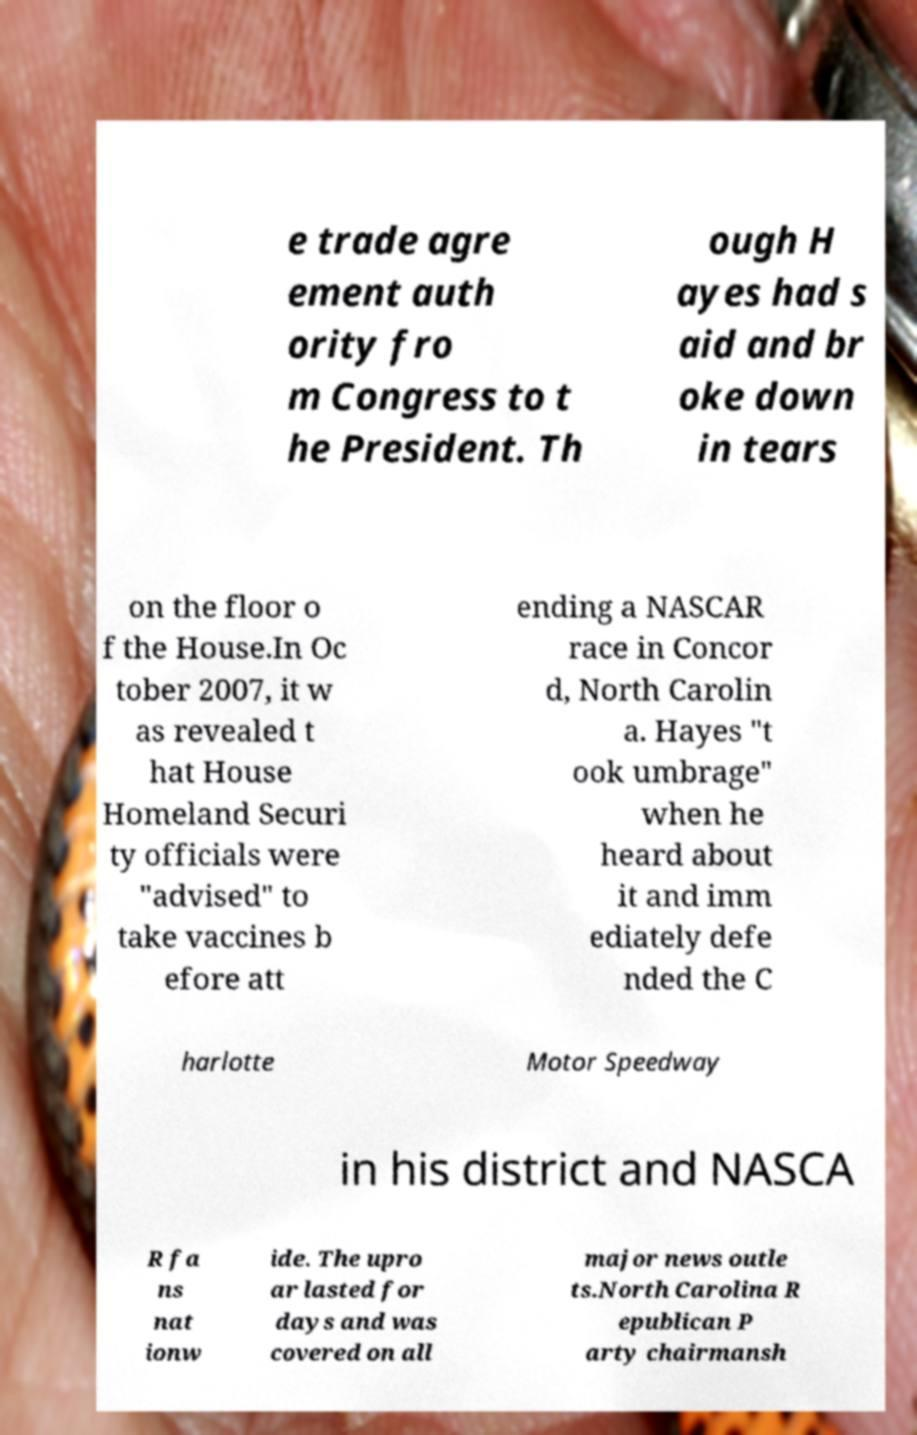Could you assist in decoding the text presented in this image and type it out clearly? e trade agre ement auth ority fro m Congress to t he President. Th ough H ayes had s aid and br oke down in tears on the floor o f the House.In Oc tober 2007, it w as revealed t hat House Homeland Securi ty officials were "advised" to take vaccines b efore att ending a NASCAR race in Concor d, North Carolin a. Hayes "t ook umbrage" when he heard about it and imm ediately defe nded the C harlotte Motor Speedway in his district and NASCA R fa ns nat ionw ide. The upro ar lasted for days and was covered on all major news outle ts.North Carolina R epublican P arty chairmansh 